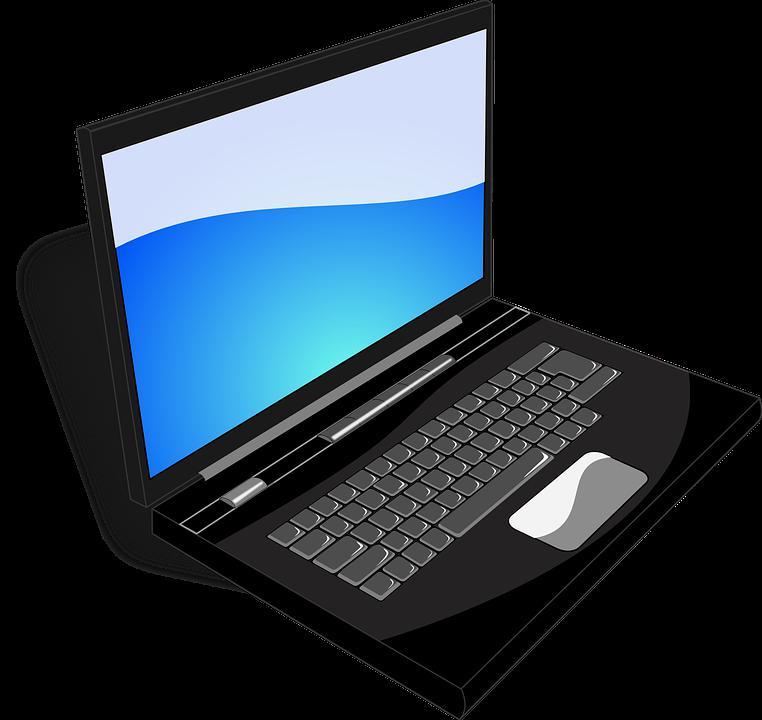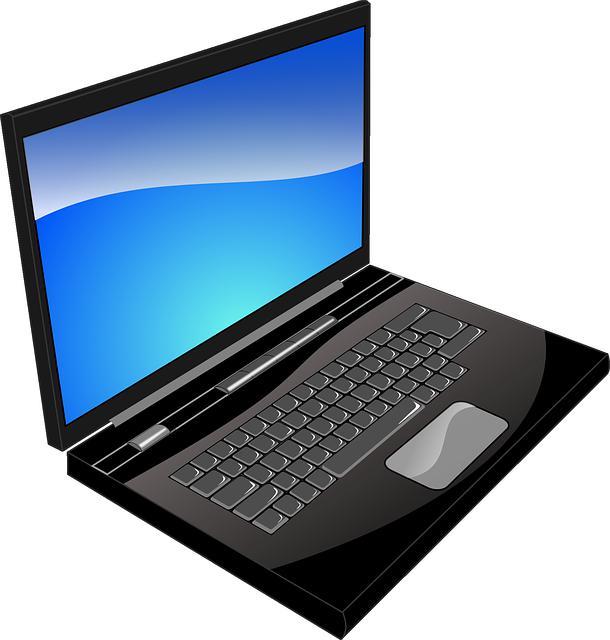The first image is the image on the left, the second image is the image on the right. Examine the images to the left and right. Is the description "Both of the laptops are facing in the same direction." accurate? Answer yes or no. Yes. The first image is the image on the left, the second image is the image on the right. Given the left and right images, does the statement "Each image shows one opened laptop angled so the screen faces rightward." hold true? Answer yes or no. Yes. 